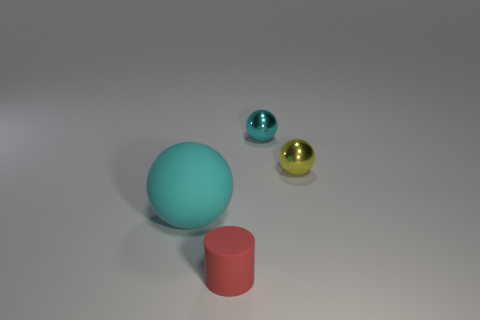There is a ball that is to the left of the cyan metal sphere; is it the same size as the thing that is behind the yellow metal ball?
Give a very brief answer. No. How many other objects are the same shape as the red matte thing?
Your answer should be very brief. 0. What is the material of the cyan object that is left of the cyan object that is behind the large cyan rubber sphere?
Give a very brief answer. Rubber. How many shiny objects are either small red things or small cyan spheres?
Make the answer very short. 1. There is a small metallic object that is in front of the cyan metallic sphere; are there any small red cylinders right of it?
Provide a succinct answer. No. What number of things are cyan spheres in front of the small yellow ball or things to the right of the large rubber ball?
Provide a succinct answer. 4. Are there any other things of the same color as the big rubber ball?
Offer a very short reply. Yes. There is a matte object in front of the cyan object that is to the left of the rubber object that is on the right side of the big sphere; what color is it?
Offer a very short reply. Red. There is a cyan thing that is to the left of the cyan sphere that is to the right of the big cyan matte thing; what size is it?
Make the answer very short. Large. There is a object that is behind the tiny rubber object and in front of the yellow object; what is it made of?
Your answer should be very brief. Rubber. 